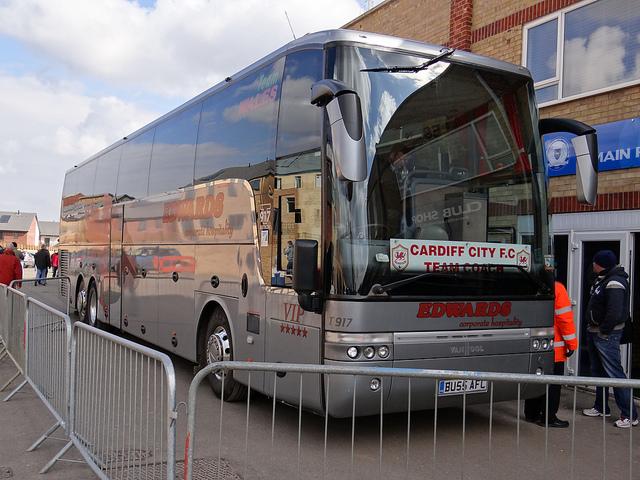How many people are standing outside of the bus?
Write a very short answer. 2. What colors is this bus?
Give a very brief answer. Silver. How many buses are there?
Give a very brief answer. 1. Is the scene mostly dark?
Concise answer only. No. What is on the banners to the right?
Concise answer only. Main. What color are the buses?
Answer briefly. Gray. What number is written on the bus?
Write a very short answer. 917. Is this a tour bus?
Give a very brief answer. Yes. Where are the bus occupants from?
Give a very brief answer. Cardiff city. What is reflecting in the window?
Answer briefly. Building. Is this a passenger train?
Write a very short answer. No. 